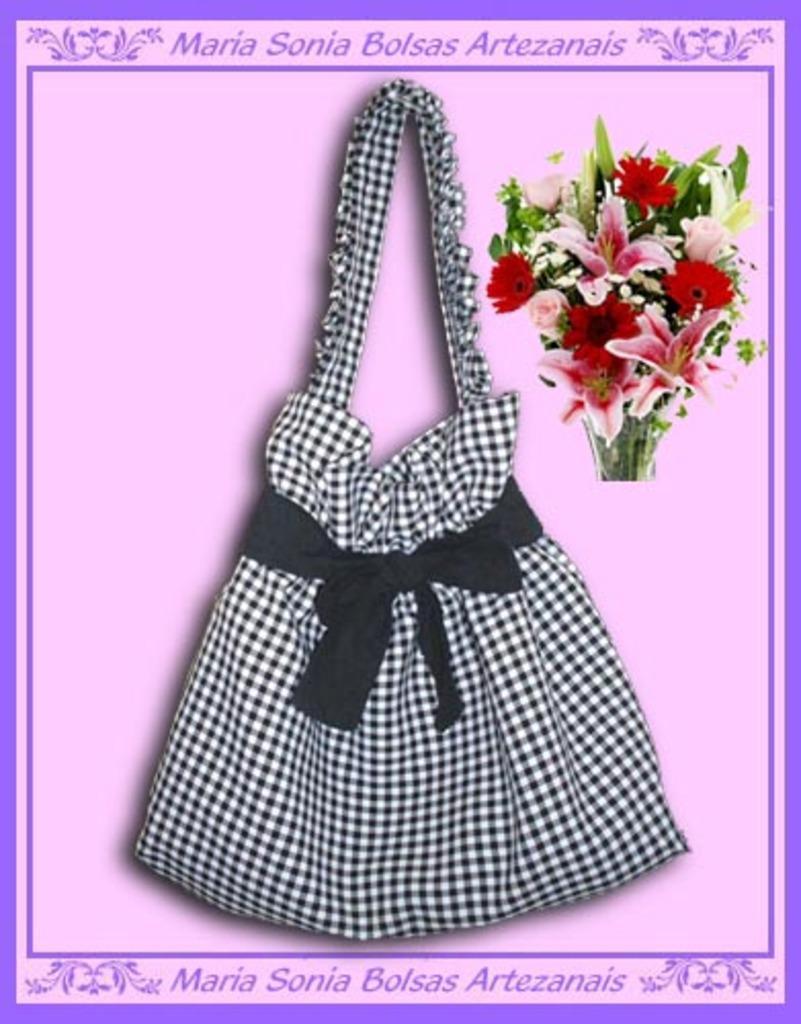Can you describe this image briefly? In this image there is a bag, there are flowers, there are leaves, there is text towards the top of the image, there is text towards the bottom of the image, the background of the image is purple in color. 